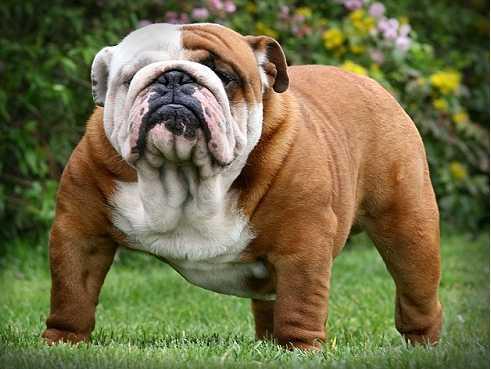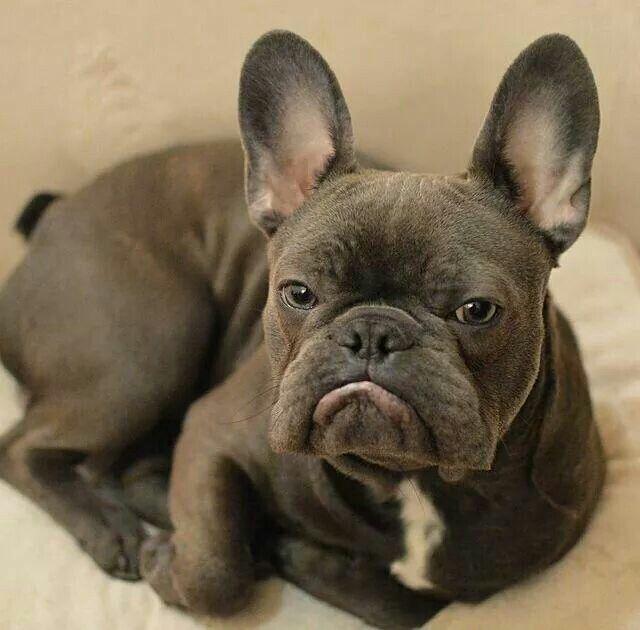The first image is the image on the left, the second image is the image on the right. For the images shown, is this caption "At least one of the dogs is in the grass." true? Answer yes or no. Yes. 